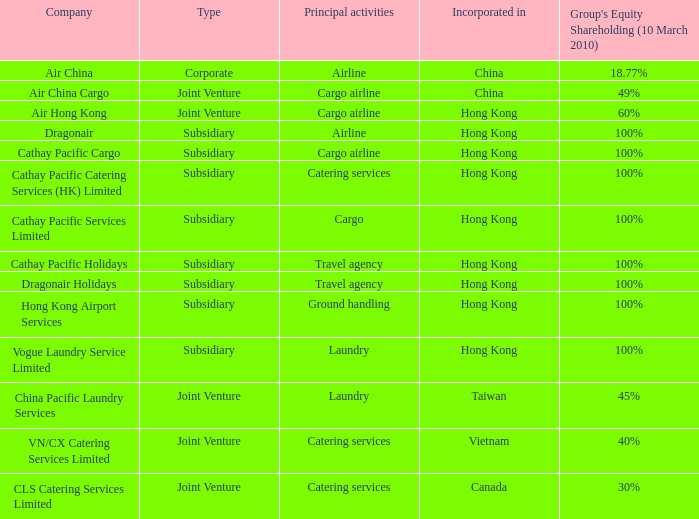Which  company's type is joint venture, and has principle activities listed as Cargo Airline and an incorporation of China? Air China Cargo. 